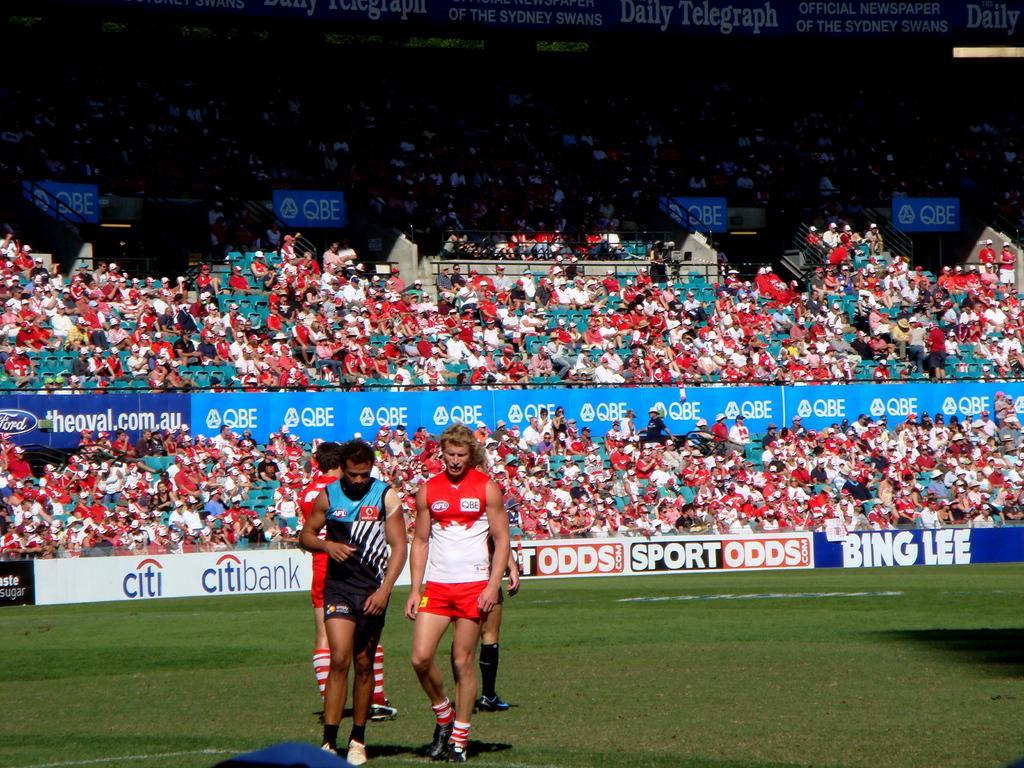Describe this image in one or two sentences. There are men in the foreground area of the image on the grassland, there are people sitting as the audience and posters on the boundaries in the background area. 